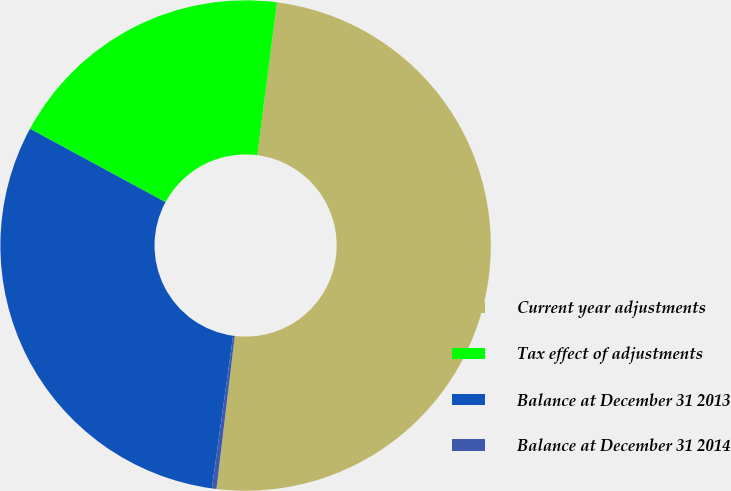Convert chart to OTSL. <chart><loc_0><loc_0><loc_500><loc_500><pie_chart><fcel>Current year adjustments<fcel>Tax effect of adjustments<fcel>Balance at December 31 2013<fcel>Balance at December 31 2014<nl><fcel>49.85%<fcel>19.15%<fcel>30.7%<fcel>0.3%<nl></chart> 